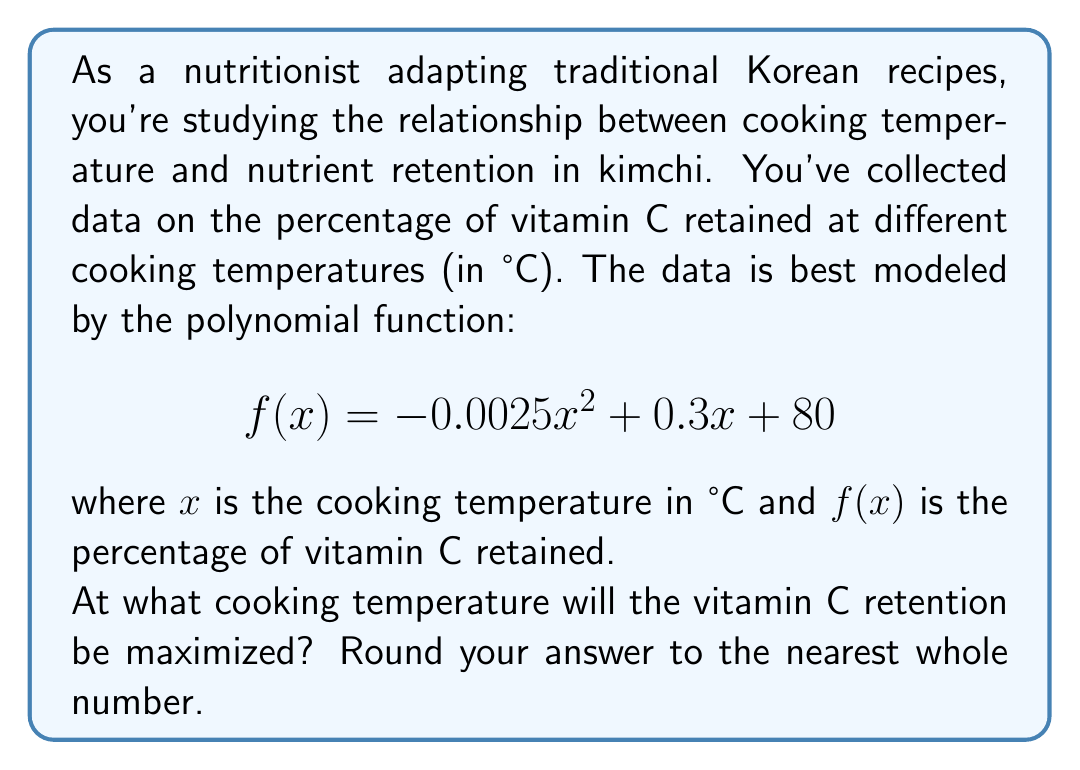What is the answer to this math problem? To find the maximum point of a quadratic function, we need to follow these steps:

1) The general form of a quadratic function is $f(x) = ax^2 + bx + c$. In this case:
   $a = -0.0025$, $b = 0.3$, and $c = 80$

2) The x-coordinate of the vertex (which represents the temperature at which vitamin C retention is maximized) can be found using the formula: $x = -\frac{b}{2a}$

3) Let's substitute our values:
   $$x = -\frac{0.3}{2(-0.0025)} = \frac{0.3}{0.005} = 60$$

4) To verify this is a maximum (not a minimum), we can check that $a < 0$, which it is in this case.

5) Rounding to the nearest whole number: 60°C

Therefore, vitamin C retention in kimchi will be maximized at a cooking temperature of 60°C.
Answer: 60°C 